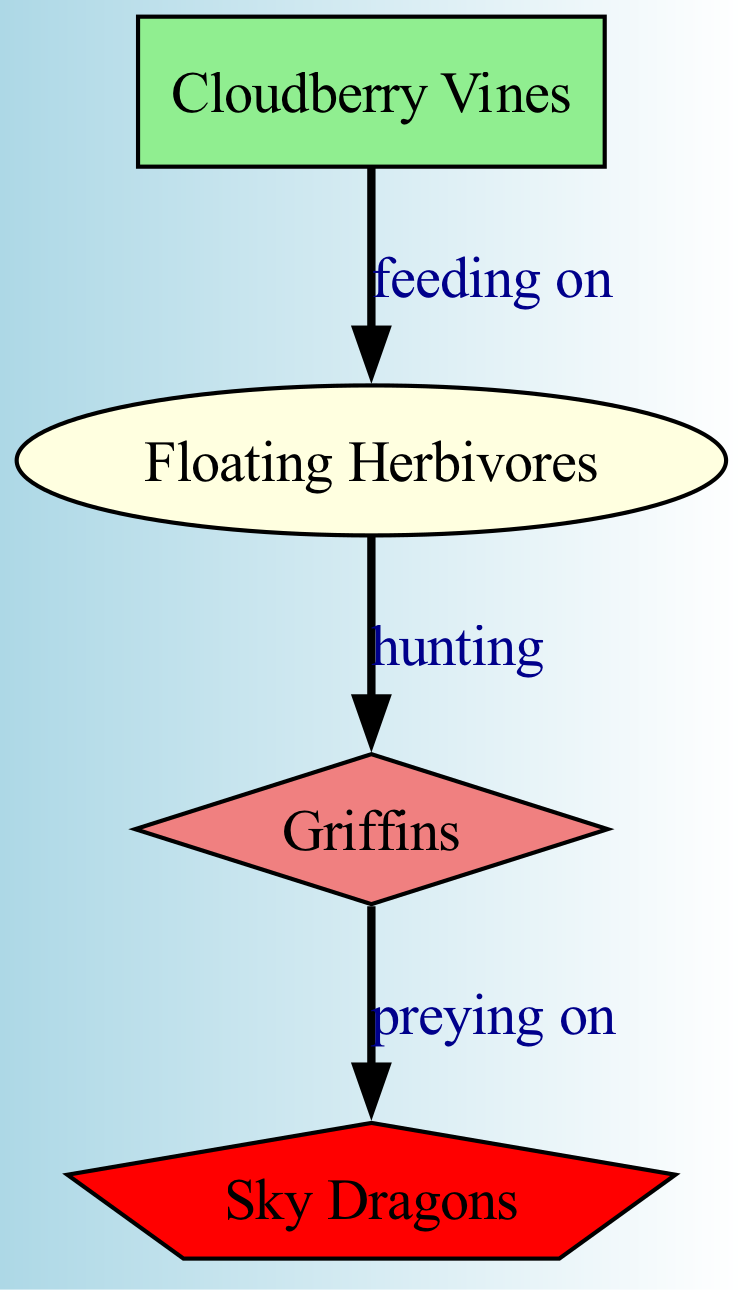What are the producers in this food chain? The producers are represented by the nodes labeled as producers, which in this case is identified as "Cloudberry Vines."
Answer: Cloudberry Vines How many nodes are there in the diagram? By counting the entries under the "nodes" section, we can identify there are four distinct nodes: Cloudberry Vines, Floating Herbivores, Griffins, and Sky Dragons.
Answer: 4 Who is at the apex level of the food chain? The apex predator, represented in the diagram, is located at the top of the hierarchy and is "Sky Dragons."
Answer: Sky Dragons What do floating herbivores feed on? The diagram shows a direct feeding relationship, indicating that Floating Herbivores are linked by the label "feeding on" to Cloudberry Vines, thus they consume these plants.
Answer: Cloudberry Vines How many edges are present in the diagram? Edges represent the feeding and predatory relationships between nodes. Here, we can see three connections (from Cloudberry Vines to Floating Herbivores, from Floating Herbivores to Griffins, and from Griffins to Sky Dragons).
Answer: 3 What relationship exists between Griffins and Sky Dragons? Looking at the edges, the relationship defined by the edge shows that Griffins "prey on" Sky Dragons, indicating that Griffins are a secondary component in relation to the apex predator.
Answer: preying on Which creatures are categorized as primary consumers? Primary consumers in the food chain are those that feed directly on producers. Based on the diagram, the only primary consumer present is Floating Herbivores.
Answer: Floating Herbivores What is the role of Cloudberry Vines in the food chain? Cloudberry Vines function as producers, meaning they convert sunlight and nutrients into energy for themselves, which feeds the primary consumers within the ecosystem displayed in the diagram.
Answer: producer What type of relationship exists between Floating Herbivores and Griffins? The edge between these two nodes indicates a "hunting" relationship where Griffins hunt Floating Herbivores for sustenance, making this a predatory relationship.
Answer: hunting 